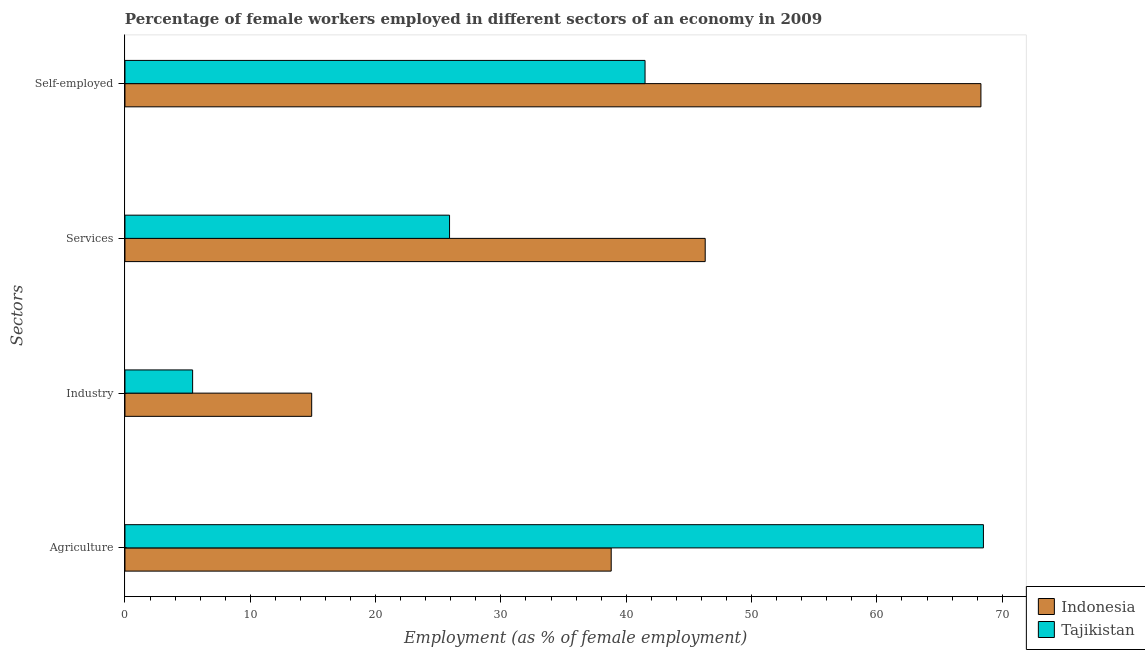How many different coloured bars are there?
Ensure brevity in your answer.  2. Are the number of bars per tick equal to the number of legend labels?
Your response must be concise. Yes. What is the label of the 4th group of bars from the top?
Provide a short and direct response. Agriculture. What is the percentage of female workers in services in Tajikistan?
Give a very brief answer. 25.9. Across all countries, what is the maximum percentage of female workers in services?
Your answer should be compact. 46.3. Across all countries, what is the minimum percentage of female workers in industry?
Offer a very short reply. 5.4. In which country was the percentage of female workers in industry maximum?
Provide a short and direct response. Indonesia. In which country was the percentage of self employed female workers minimum?
Your answer should be compact. Tajikistan. What is the total percentage of female workers in industry in the graph?
Give a very brief answer. 20.3. What is the difference between the percentage of female workers in agriculture in Indonesia and that in Tajikistan?
Provide a short and direct response. -29.7. What is the difference between the percentage of female workers in agriculture in Indonesia and the percentage of female workers in services in Tajikistan?
Your answer should be very brief. 12.9. What is the average percentage of female workers in agriculture per country?
Make the answer very short. 53.65. What is the difference between the percentage of female workers in agriculture and percentage of female workers in industry in Tajikistan?
Make the answer very short. 63.1. In how many countries, is the percentage of female workers in agriculture greater than 4 %?
Offer a terse response. 2. What is the ratio of the percentage of female workers in industry in Tajikistan to that in Indonesia?
Your answer should be very brief. 0.36. Is the difference between the percentage of female workers in services in Tajikistan and Indonesia greater than the difference between the percentage of female workers in agriculture in Tajikistan and Indonesia?
Your answer should be compact. No. What is the difference between the highest and the second highest percentage of female workers in services?
Your response must be concise. 20.4. What is the difference between the highest and the lowest percentage of self employed female workers?
Your answer should be very brief. 26.8. Is the sum of the percentage of female workers in services in Tajikistan and Indonesia greater than the maximum percentage of female workers in industry across all countries?
Your response must be concise. Yes. Is it the case that in every country, the sum of the percentage of self employed female workers and percentage of female workers in agriculture is greater than the sum of percentage of female workers in services and percentage of female workers in industry?
Offer a very short reply. No. What does the 1st bar from the top in Services represents?
Make the answer very short. Tajikistan. What does the 2nd bar from the bottom in Agriculture represents?
Your answer should be compact. Tajikistan. How many countries are there in the graph?
Make the answer very short. 2. Does the graph contain grids?
Your response must be concise. No. How many legend labels are there?
Ensure brevity in your answer.  2. What is the title of the graph?
Make the answer very short. Percentage of female workers employed in different sectors of an economy in 2009. Does "Belgium" appear as one of the legend labels in the graph?
Offer a very short reply. No. What is the label or title of the X-axis?
Provide a short and direct response. Employment (as % of female employment). What is the label or title of the Y-axis?
Make the answer very short. Sectors. What is the Employment (as % of female employment) in Indonesia in Agriculture?
Ensure brevity in your answer.  38.8. What is the Employment (as % of female employment) of Tajikistan in Agriculture?
Your response must be concise. 68.5. What is the Employment (as % of female employment) of Indonesia in Industry?
Offer a terse response. 14.9. What is the Employment (as % of female employment) of Tajikistan in Industry?
Ensure brevity in your answer.  5.4. What is the Employment (as % of female employment) of Indonesia in Services?
Give a very brief answer. 46.3. What is the Employment (as % of female employment) in Tajikistan in Services?
Your answer should be compact. 25.9. What is the Employment (as % of female employment) of Indonesia in Self-employed?
Make the answer very short. 68.3. What is the Employment (as % of female employment) of Tajikistan in Self-employed?
Keep it short and to the point. 41.5. Across all Sectors, what is the maximum Employment (as % of female employment) of Indonesia?
Ensure brevity in your answer.  68.3. Across all Sectors, what is the maximum Employment (as % of female employment) of Tajikistan?
Ensure brevity in your answer.  68.5. Across all Sectors, what is the minimum Employment (as % of female employment) in Indonesia?
Keep it short and to the point. 14.9. Across all Sectors, what is the minimum Employment (as % of female employment) of Tajikistan?
Provide a short and direct response. 5.4. What is the total Employment (as % of female employment) of Indonesia in the graph?
Offer a terse response. 168.3. What is the total Employment (as % of female employment) of Tajikistan in the graph?
Your response must be concise. 141.3. What is the difference between the Employment (as % of female employment) in Indonesia in Agriculture and that in Industry?
Make the answer very short. 23.9. What is the difference between the Employment (as % of female employment) of Tajikistan in Agriculture and that in Industry?
Your answer should be very brief. 63.1. What is the difference between the Employment (as % of female employment) of Tajikistan in Agriculture and that in Services?
Offer a terse response. 42.6. What is the difference between the Employment (as % of female employment) of Indonesia in Agriculture and that in Self-employed?
Provide a short and direct response. -29.5. What is the difference between the Employment (as % of female employment) of Indonesia in Industry and that in Services?
Give a very brief answer. -31.4. What is the difference between the Employment (as % of female employment) of Tajikistan in Industry and that in Services?
Provide a short and direct response. -20.5. What is the difference between the Employment (as % of female employment) of Indonesia in Industry and that in Self-employed?
Your answer should be compact. -53.4. What is the difference between the Employment (as % of female employment) of Tajikistan in Industry and that in Self-employed?
Your answer should be compact. -36.1. What is the difference between the Employment (as % of female employment) in Tajikistan in Services and that in Self-employed?
Ensure brevity in your answer.  -15.6. What is the difference between the Employment (as % of female employment) in Indonesia in Agriculture and the Employment (as % of female employment) in Tajikistan in Industry?
Your response must be concise. 33.4. What is the difference between the Employment (as % of female employment) of Indonesia in Agriculture and the Employment (as % of female employment) of Tajikistan in Services?
Keep it short and to the point. 12.9. What is the difference between the Employment (as % of female employment) in Indonesia in Agriculture and the Employment (as % of female employment) in Tajikistan in Self-employed?
Provide a short and direct response. -2.7. What is the difference between the Employment (as % of female employment) in Indonesia in Industry and the Employment (as % of female employment) in Tajikistan in Self-employed?
Provide a succinct answer. -26.6. What is the average Employment (as % of female employment) of Indonesia per Sectors?
Your response must be concise. 42.08. What is the average Employment (as % of female employment) of Tajikistan per Sectors?
Give a very brief answer. 35.33. What is the difference between the Employment (as % of female employment) in Indonesia and Employment (as % of female employment) in Tajikistan in Agriculture?
Make the answer very short. -29.7. What is the difference between the Employment (as % of female employment) of Indonesia and Employment (as % of female employment) of Tajikistan in Services?
Provide a short and direct response. 20.4. What is the difference between the Employment (as % of female employment) of Indonesia and Employment (as % of female employment) of Tajikistan in Self-employed?
Keep it short and to the point. 26.8. What is the ratio of the Employment (as % of female employment) in Indonesia in Agriculture to that in Industry?
Keep it short and to the point. 2.6. What is the ratio of the Employment (as % of female employment) in Tajikistan in Agriculture to that in Industry?
Offer a terse response. 12.69. What is the ratio of the Employment (as % of female employment) of Indonesia in Agriculture to that in Services?
Provide a short and direct response. 0.84. What is the ratio of the Employment (as % of female employment) in Tajikistan in Agriculture to that in Services?
Keep it short and to the point. 2.64. What is the ratio of the Employment (as % of female employment) of Indonesia in Agriculture to that in Self-employed?
Your answer should be compact. 0.57. What is the ratio of the Employment (as % of female employment) of Tajikistan in Agriculture to that in Self-employed?
Give a very brief answer. 1.65. What is the ratio of the Employment (as % of female employment) in Indonesia in Industry to that in Services?
Ensure brevity in your answer.  0.32. What is the ratio of the Employment (as % of female employment) in Tajikistan in Industry to that in Services?
Provide a short and direct response. 0.21. What is the ratio of the Employment (as % of female employment) in Indonesia in Industry to that in Self-employed?
Your answer should be compact. 0.22. What is the ratio of the Employment (as % of female employment) in Tajikistan in Industry to that in Self-employed?
Your response must be concise. 0.13. What is the ratio of the Employment (as % of female employment) in Indonesia in Services to that in Self-employed?
Keep it short and to the point. 0.68. What is the ratio of the Employment (as % of female employment) of Tajikistan in Services to that in Self-employed?
Provide a succinct answer. 0.62. What is the difference between the highest and the lowest Employment (as % of female employment) in Indonesia?
Your answer should be compact. 53.4. What is the difference between the highest and the lowest Employment (as % of female employment) in Tajikistan?
Your answer should be compact. 63.1. 